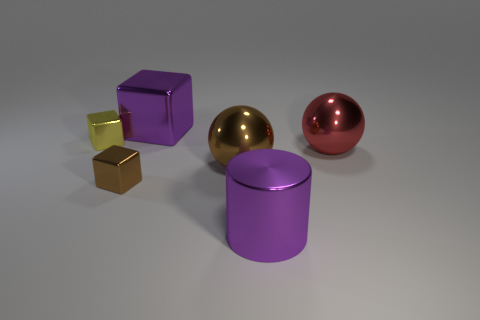How many things are both right of the metal cylinder and to the left of the big purple block?
Offer a terse response. 0. What is the color of the big shiny block?
Offer a terse response. Purple. Are there any brown blocks that have the same material as the purple cylinder?
Make the answer very short. Yes. Are there any purple blocks that are on the right side of the brown shiny thing that is to the left of the large brown shiny thing that is on the right side of the big purple cube?
Give a very brief answer. Yes. There is a big cylinder; are there any large metal cylinders behind it?
Provide a short and direct response. No. Is there another big cylinder that has the same color as the large cylinder?
Ensure brevity in your answer.  No. How many tiny things are either purple cylinders or brown rubber objects?
Offer a very short reply. 0. There is a large metal thing on the right side of the purple thing in front of the big purple object that is behind the red metallic object; what is its shape?
Provide a succinct answer. Sphere. What number of green objects are tiny shiny blocks or big metallic cubes?
Your answer should be very brief. 0. Is the number of small objects behind the large purple shiny cylinder the same as the number of big metallic objects that are on the left side of the yellow shiny object?
Ensure brevity in your answer.  No. 